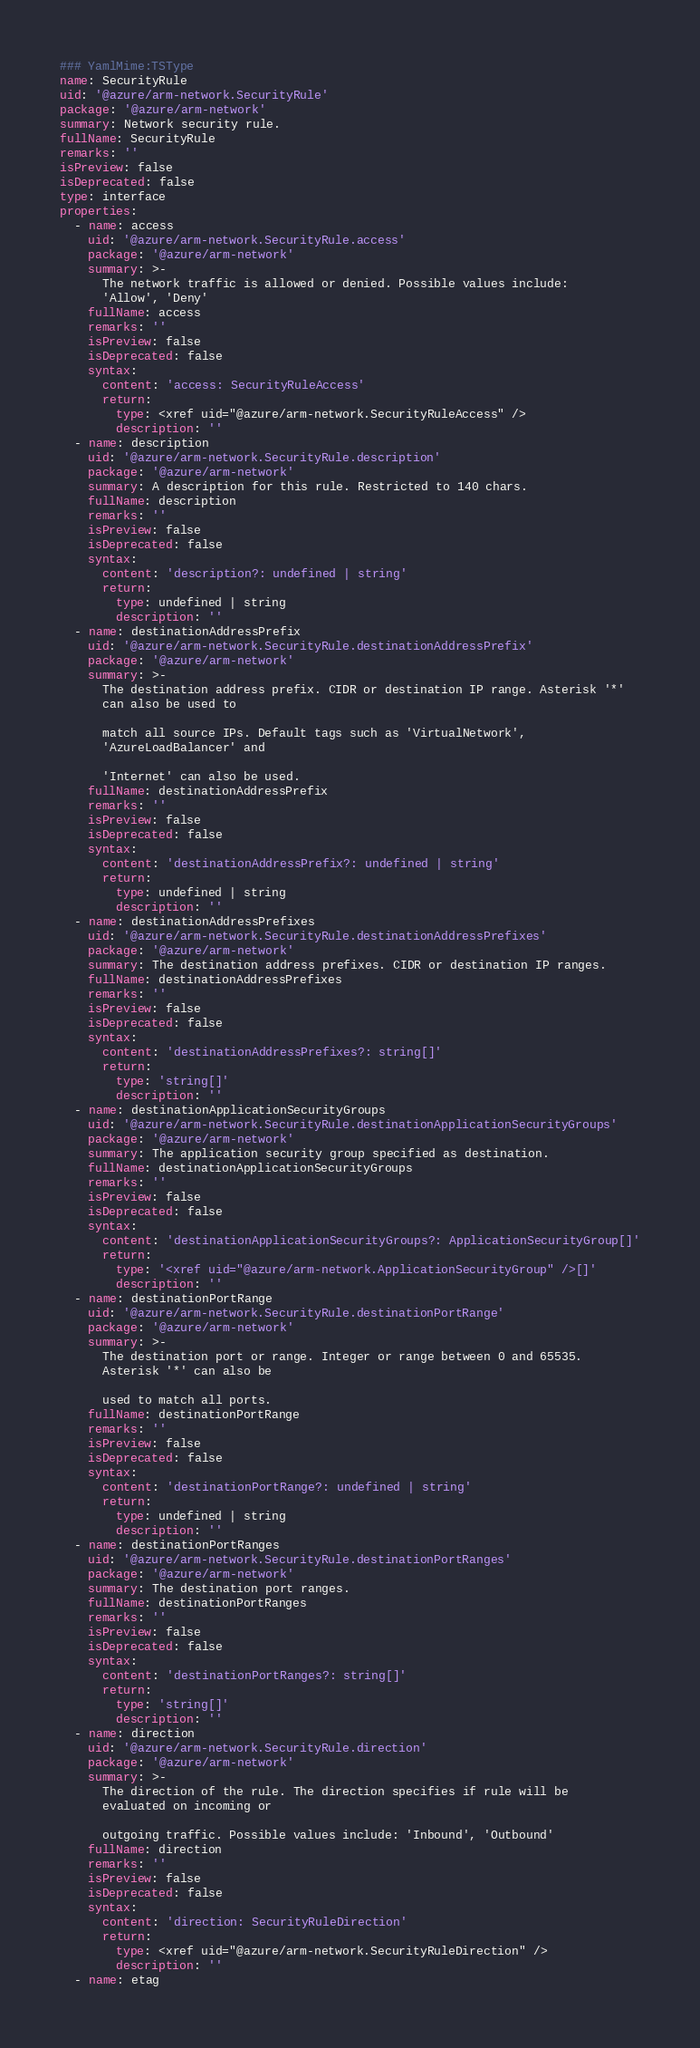<code> <loc_0><loc_0><loc_500><loc_500><_YAML_>### YamlMime:TSType
name: SecurityRule
uid: '@azure/arm-network.SecurityRule'
package: '@azure/arm-network'
summary: Network security rule.
fullName: SecurityRule
remarks: ''
isPreview: false
isDeprecated: false
type: interface
properties:
  - name: access
    uid: '@azure/arm-network.SecurityRule.access'
    package: '@azure/arm-network'
    summary: >-
      The network traffic is allowed or denied. Possible values include:
      'Allow', 'Deny'
    fullName: access
    remarks: ''
    isPreview: false
    isDeprecated: false
    syntax:
      content: 'access: SecurityRuleAccess'
      return:
        type: <xref uid="@azure/arm-network.SecurityRuleAccess" />
        description: ''
  - name: description
    uid: '@azure/arm-network.SecurityRule.description'
    package: '@azure/arm-network'
    summary: A description for this rule. Restricted to 140 chars.
    fullName: description
    remarks: ''
    isPreview: false
    isDeprecated: false
    syntax:
      content: 'description?: undefined | string'
      return:
        type: undefined | string
        description: ''
  - name: destinationAddressPrefix
    uid: '@azure/arm-network.SecurityRule.destinationAddressPrefix'
    package: '@azure/arm-network'
    summary: >-
      The destination address prefix. CIDR or destination IP range. Asterisk '*'
      can also be used to

      match all source IPs. Default tags such as 'VirtualNetwork',
      'AzureLoadBalancer' and

      'Internet' can also be used.
    fullName: destinationAddressPrefix
    remarks: ''
    isPreview: false
    isDeprecated: false
    syntax:
      content: 'destinationAddressPrefix?: undefined | string'
      return:
        type: undefined | string
        description: ''
  - name: destinationAddressPrefixes
    uid: '@azure/arm-network.SecurityRule.destinationAddressPrefixes'
    package: '@azure/arm-network'
    summary: The destination address prefixes. CIDR or destination IP ranges.
    fullName: destinationAddressPrefixes
    remarks: ''
    isPreview: false
    isDeprecated: false
    syntax:
      content: 'destinationAddressPrefixes?: string[]'
      return:
        type: 'string[]'
        description: ''
  - name: destinationApplicationSecurityGroups
    uid: '@azure/arm-network.SecurityRule.destinationApplicationSecurityGroups'
    package: '@azure/arm-network'
    summary: The application security group specified as destination.
    fullName: destinationApplicationSecurityGroups
    remarks: ''
    isPreview: false
    isDeprecated: false
    syntax:
      content: 'destinationApplicationSecurityGroups?: ApplicationSecurityGroup[]'
      return:
        type: '<xref uid="@azure/arm-network.ApplicationSecurityGroup" />[]'
        description: ''
  - name: destinationPortRange
    uid: '@azure/arm-network.SecurityRule.destinationPortRange'
    package: '@azure/arm-network'
    summary: >-
      The destination port or range. Integer or range between 0 and 65535.
      Asterisk '*' can also be

      used to match all ports.
    fullName: destinationPortRange
    remarks: ''
    isPreview: false
    isDeprecated: false
    syntax:
      content: 'destinationPortRange?: undefined | string'
      return:
        type: undefined | string
        description: ''
  - name: destinationPortRanges
    uid: '@azure/arm-network.SecurityRule.destinationPortRanges'
    package: '@azure/arm-network'
    summary: The destination port ranges.
    fullName: destinationPortRanges
    remarks: ''
    isPreview: false
    isDeprecated: false
    syntax:
      content: 'destinationPortRanges?: string[]'
      return:
        type: 'string[]'
        description: ''
  - name: direction
    uid: '@azure/arm-network.SecurityRule.direction'
    package: '@azure/arm-network'
    summary: >-
      The direction of the rule. The direction specifies if rule will be
      evaluated on incoming or

      outgoing traffic. Possible values include: 'Inbound', 'Outbound'
    fullName: direction
    remarks: ''
    isPreview: false
    isDeprecated: false
    syntax:
      content: 'direction: SecurityRuleDirection'
      return:
        type: <xref uid="@azure/arm-network.SecurityRuleDirection" />
        description: ''
  - name: etag</code> 